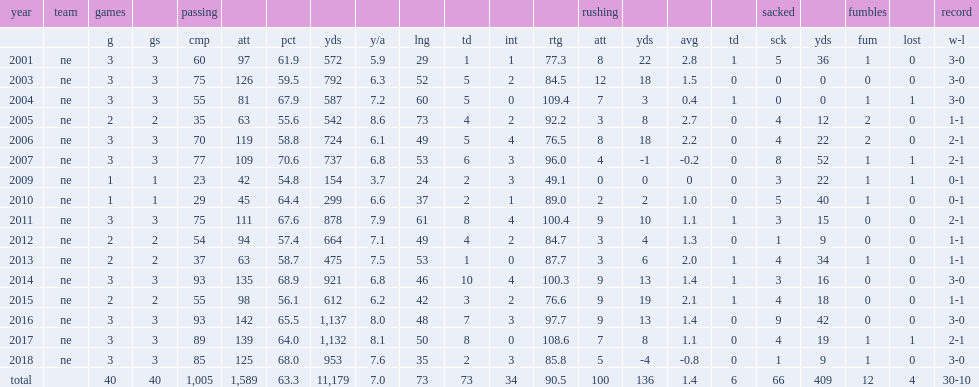What was the number of passing yards that brady got in 2009? 154.0. 